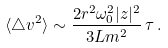<formula> <loc_0><loc_0><loc_500><loc_500>\langle \triangle v ^ { 2 } \rangle \sim \frac { 2 r ^ { 2 } \omega _ { 0 } ^ { 2 } | z | ^ { 2 } } { 3 L m ^ { 2 } } \, \tau \, .</formula> 